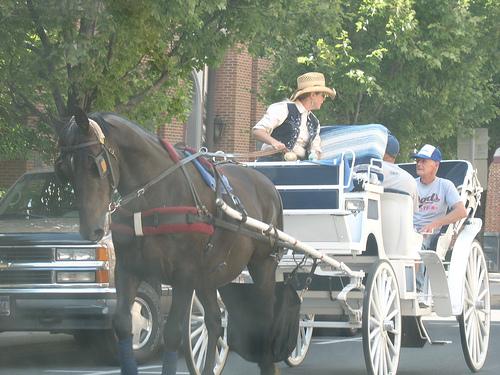What kind of hat is the driver wearing?
Be succinct. Cowboy. How many persons are wear hats in this picture?
Be succinct. 3. What color is the buggy?
Write a very short answer. White. 